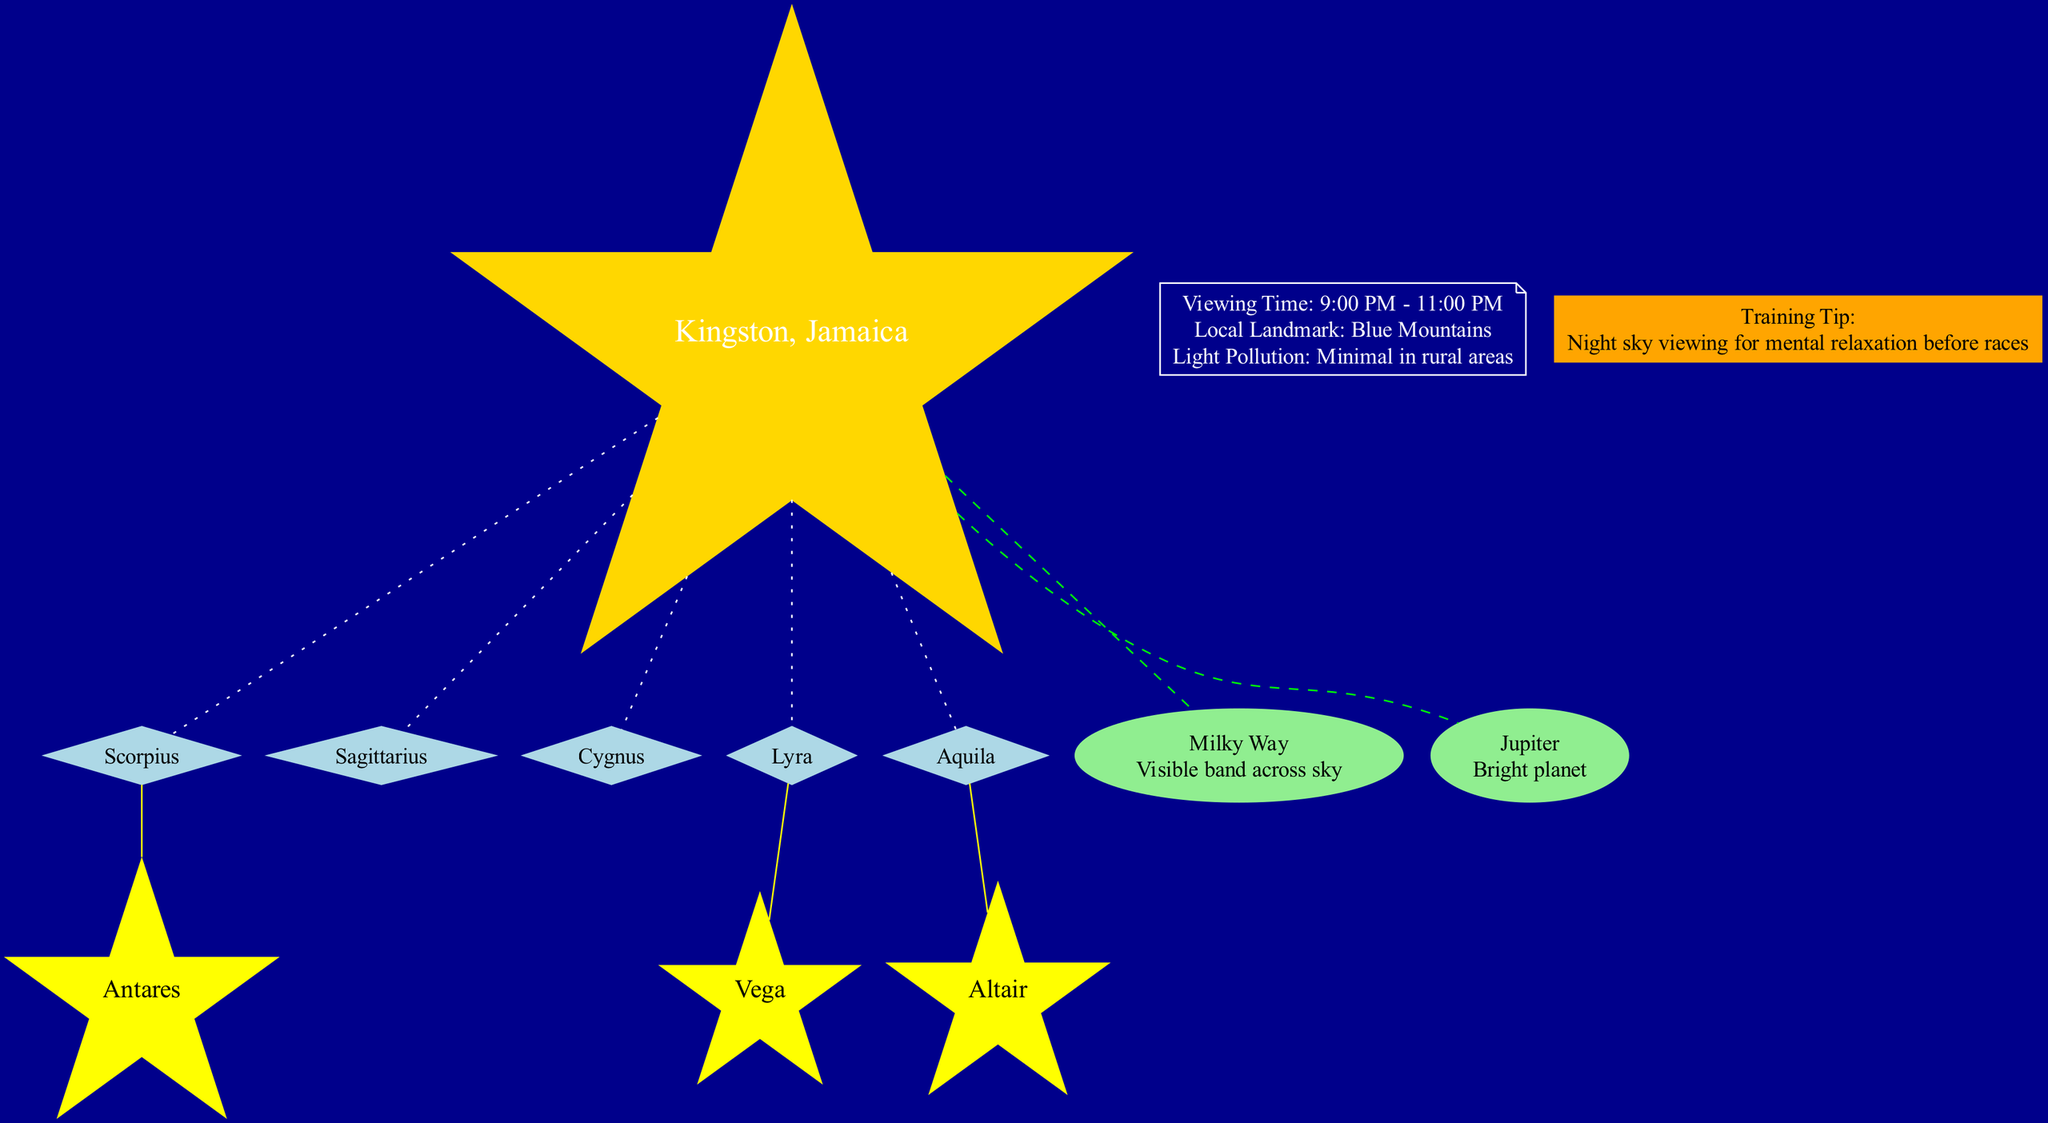What is the viewing time for the night sky? The diagram shows a specific node labeled with the viewing time information, which is indicated as '9:00 PM - 11:00 PM'.
Answer: 9:00 PM - 11:00 PM Which constellation features the bright star Antares? By examining the edges connecting the nodes, Antares is directly linked to the constellation Scorpius.
Answer: Scorpius How many major constellations are highlighted in the diagram? The count of nodes labeled as major constellations can be seen; there are five listed: Scorpius, Sagittarius, Cygnus, Lyra, and Aquila.
Answer: 5 What celestial object is described as a 'Bright planet'? The information shows the celestial object Jupiter with the description 'Bright planet' directly relating to its node.
Answer: Jupiter Which constellation is connected to the bright star Vega? The link between Vega and its associated constellation is evident as Vega is directly connected to the node for Lyra.
Answer: Lyra What is the local landmark mentioned in the information? The information node lists 'Blue Mountains' as the local landmark in Kingston, Jamaica.
Answer: Blue Mountains How many bright stars are listed in the diagram? The number of bright stars can be counted by reviewing the individual nodes that represent stars; there are three bright stars listed.
Answer: 3 What is the training tip provided in the diagram? This information can be traced in the training tip node, specifically stated as 'Night sky viewing for mental relaxation before races'.
Answer: Night sky viewing for mental relaxation before races Which constellation is connected to the star Altair? Altair is indicated to have a direct edge connecting it to the constellation Aquila, which shows their relationship clearly in the diagram.
Answer: Aquila 